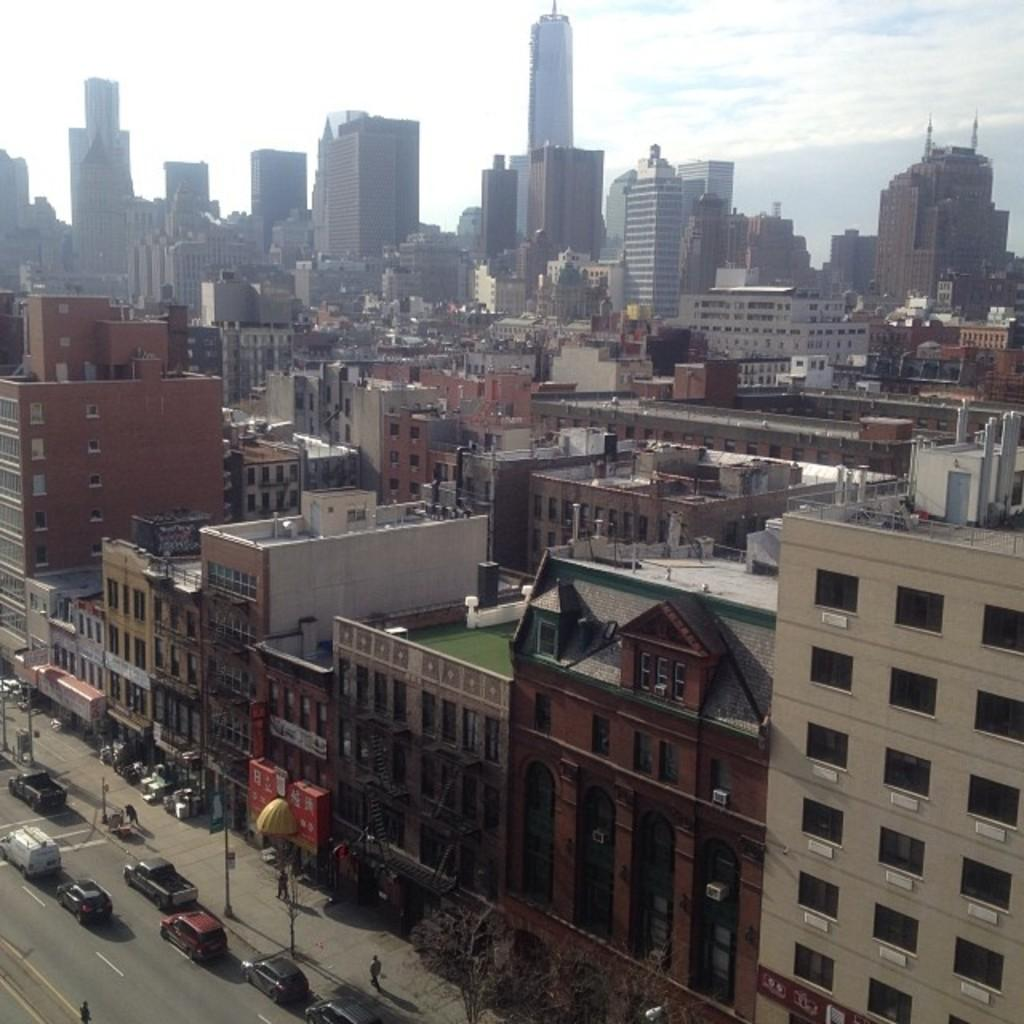What type of structures can be seen in the image? There are many buildings and skyscrapers in the image. What is located at the bottom of the image? There is a road at the bottom of the image. What is happening on the road? There are many cars on the road. What can be seen above the buildings and cars in the image? The sky is visible at the top of the image. Can you see any partners or fangs in the image? There are no partners or fangs present in the image. What type of protest is happening in the image? There is no protest depicted in the image; it features buildings, skyscrapers, a road, cars, and the sky. 